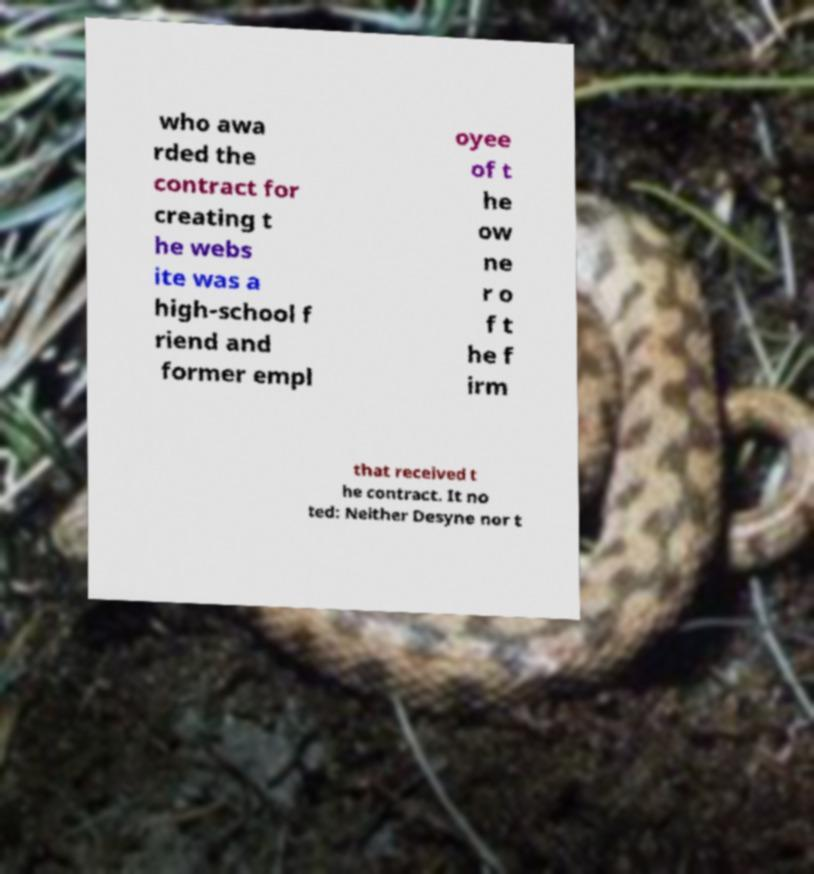What messages or text are displayed in this image? I need them in a readable, typed format. who awa rded the contract for creating t he webs ite was a high-school f riend and former empl oyee of t he ow ne r o f t he f irm that received t he contract. It no ted: Neither Desyne nor t 